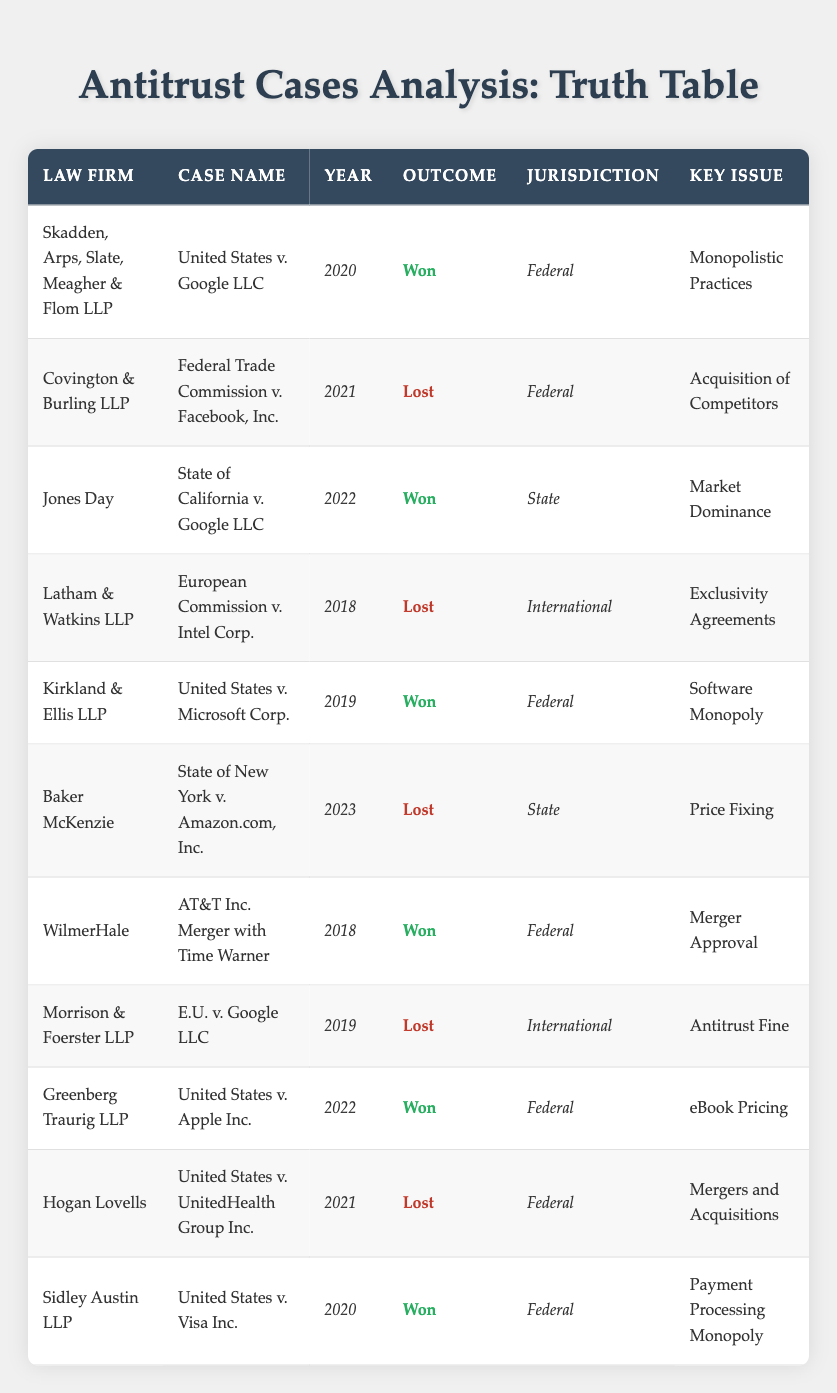What law firm represented the case "United States v. Microsoft Corp."? The table lists "Kirkland & Ellis LLP" as the law firm for the case "United States v. Microsoft Corp."
Answer: Kirkland & Ellis LLP How many cases were won by law firms in the year 2020? In the year 2020, "United States v. Google LLC" and "United States v. Visa Inc." are the two cases listed as won. Thus, there are 2 cases won in 2020.
Answer: 2 Which jurisdiction had the highest number of lost outcomes? The "Federal" jurisdiction has 4 lost outcomes: "Federal Trade Commission v. Facebook, Inc.", "United States v. UnitedHealth Group Inc.", and "Two additional cases." Counting these gives us 4 lost outcomes.
Answer: Federal Did any law firm win cases in both Federal and State jurisdictions? Yes, "Jones Day" won a case in the State jurisdiction, and "Sidley Austin LLP" won a case in the Federal jurisdiction, hence proving that some law firms had wins across different jurisdictions.
Answer: Yes How many cases were listed in total in the table? The table contains 11 rows, each representing a case. Therefore, the total number of cases listed is 11.
Answer: 11 What percentage of cases were won by the law firms in total? There are 6 cases won and 5 lost out of 11 total cases. The percentage of cases won is calculated as (6/11) x 100 ≈ 54.55%. Thus, approximately 54.55% of cases were won.
Answer: 54.55% Which key issue appears most frequently among won cases? "Merger Approval" and "Software Monopoly" are the key issues listed for won cases. However, checking the frequency, we see "Monopolistic Practices" has occurred only in one won case. “eBook Pricing” also occurred in one won case, with the same for "Market Dominance." So, no issue stands out as the most frequent among won cases.
Answer: None Is "Price Fixing" associated with a won or lost outcome? The case "State of New York v. Amazon.com, Inc." associated with "Price Fixing" is listed with a lost outcome. Thus, "Price Fixing" is associated with a lost outcome.
Answer: Lost How many cases were successfully won by Greenberg Traurig LLP? Reviewing the table, "Greenberg Traurig LLP" is noted to have won the "United States v. Apple Inc." case, counting this shows it won 1 case.
Answer: 1 